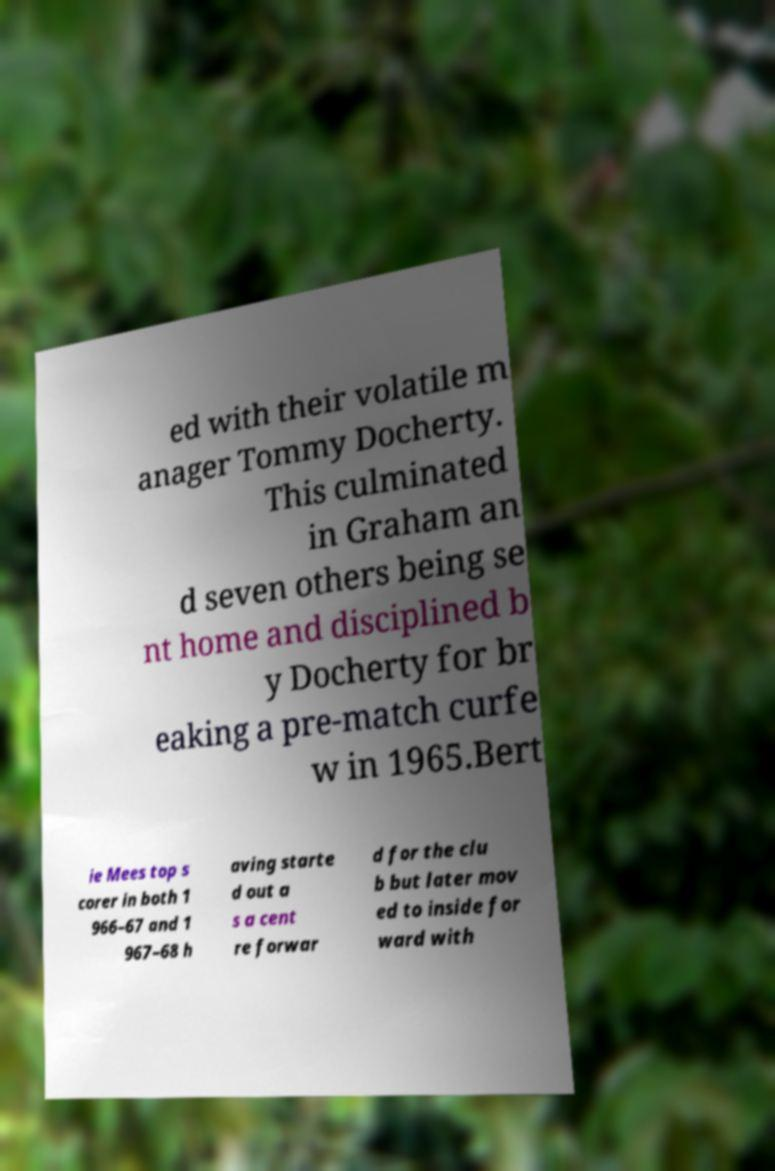Please identify and transcribe the text found in this image. ed with their volatile m anager Tommy Docherty. This culminated in Graham an d seven others being se nt home and disciplined b y Docherty for br eaking a pre-match curfe w in 1965.Bert ie Mees top s corer in both 1 966–67 and 1 967–68 h aving starte d out a s a cent re forwar d for the clu b but later mov ed to inside for ward with 